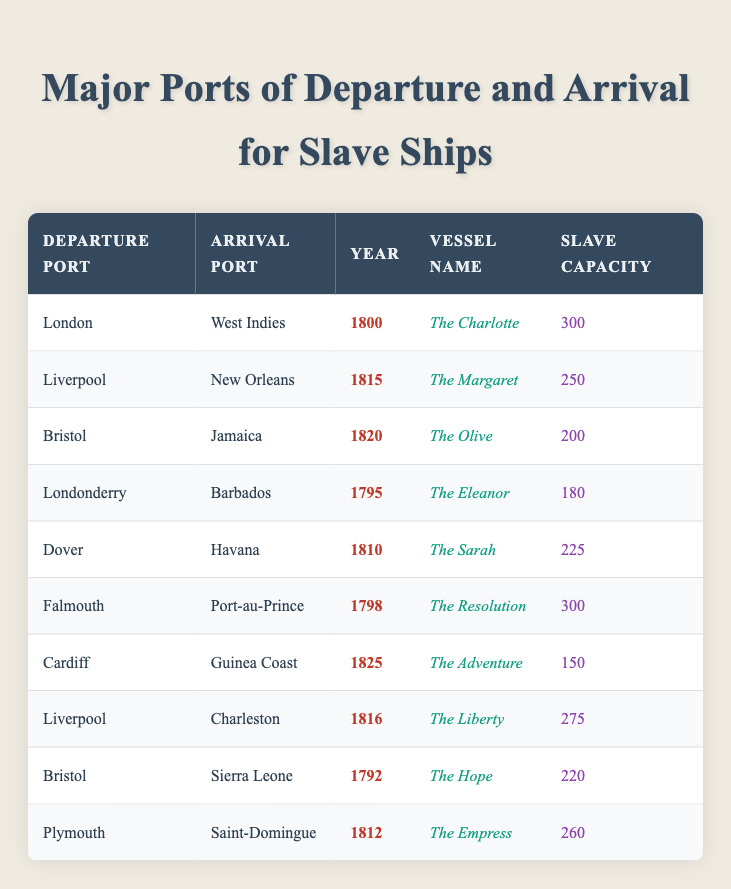What was the vessel with the highest slave capacity? By examining the "Slave Capacity" column in the table, I notice that "The Charlotte" and "The Resolution" both have the highest capacity listed, which is 300 slaves. Hence, there are two vessels tied for the highest capacity.
Answer: The Charlotte and The Resolution Which port had the most arrivals listed in the table? I look at the "Arrival Port" column and count the frequency of each port. "West Indies," "New Orleans," "Jamaica," "Barbados," "Havana," "Port-au-Prince," "Guinea Coast," "Charleston," "Sierra Leone," and "Saint-Domingue" are all unique entries. Each appears only once, indicating no particular port has more than one shipping entry.
Answer: None, all ports appear once What year saw the earliest documented slave ship departure? The earliest year in the table is found by scanning the "Year" column. The year 1792 (from the vessel "The Hope") is the earliest registered departure in the list.
Answer: 1792 What is the total slave capacity of all vessels departing from Bristol? I identify the rows where "Departure Port" matches "Bristol." The vessels are "The Olive" (200), and "The Hope" (220). I sum these capacities: 200 + 220 = 420. Thus, Bristol has a total capacity of 420.
Answer: 420 Did any ships arrive in the West Indies more than once? I analyze the "Arrival Port" column to see if "West Indies" appears more than once. It appears only once, associated with "The Charlotte." Thus, it did not have multiple arrivals.
Answer: No What is the average slave capacity of vessels arriving at Charleston? The "Arrival Port" column shows that "Charleston" was reached by "The Liberty" with a capacity of 275. Since there is only one entry, the average capacity is equal to that capacity itself: 275.
Answer: 275 How many vessels were involved in voyages to the Caribbean (West Indies, Jamaica, Barbados, Havana, and Port-au-Prince)? I count the entries where the "Arrival Port" matches a Caribbean destination: "The Charlotte" to "West Indies," "The Olive" to "Jamaica," "The Eleanor" to "Barbados," and "The Sarah" to "Havana," and "The Resolution" to "Port-au-Prince." There are five vessels total, confirming multiple voyages to the Caribbean.
Answer: 5 Which departure port had ships that traveled to the Guinea Coast? Looking at the table, I find "Cardiff" as the departure port linked to the "Guinea Coast" via "The Adventure." Thus, Cardiff is the answer.
Answer: Cardiff 